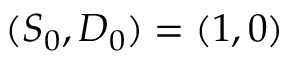<formula> <loc_0><loc_0><loc_500><loc_500>( S _ { 0 } , D _ { 0 } ) = ( 1 , 0 )</formula> 